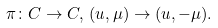<formula> <loc_0><loc_0><loc_500><loc_500>\pi \colon C \to C , \, ( u , \mu ) \to ( u , - \mu ) .</formula> 